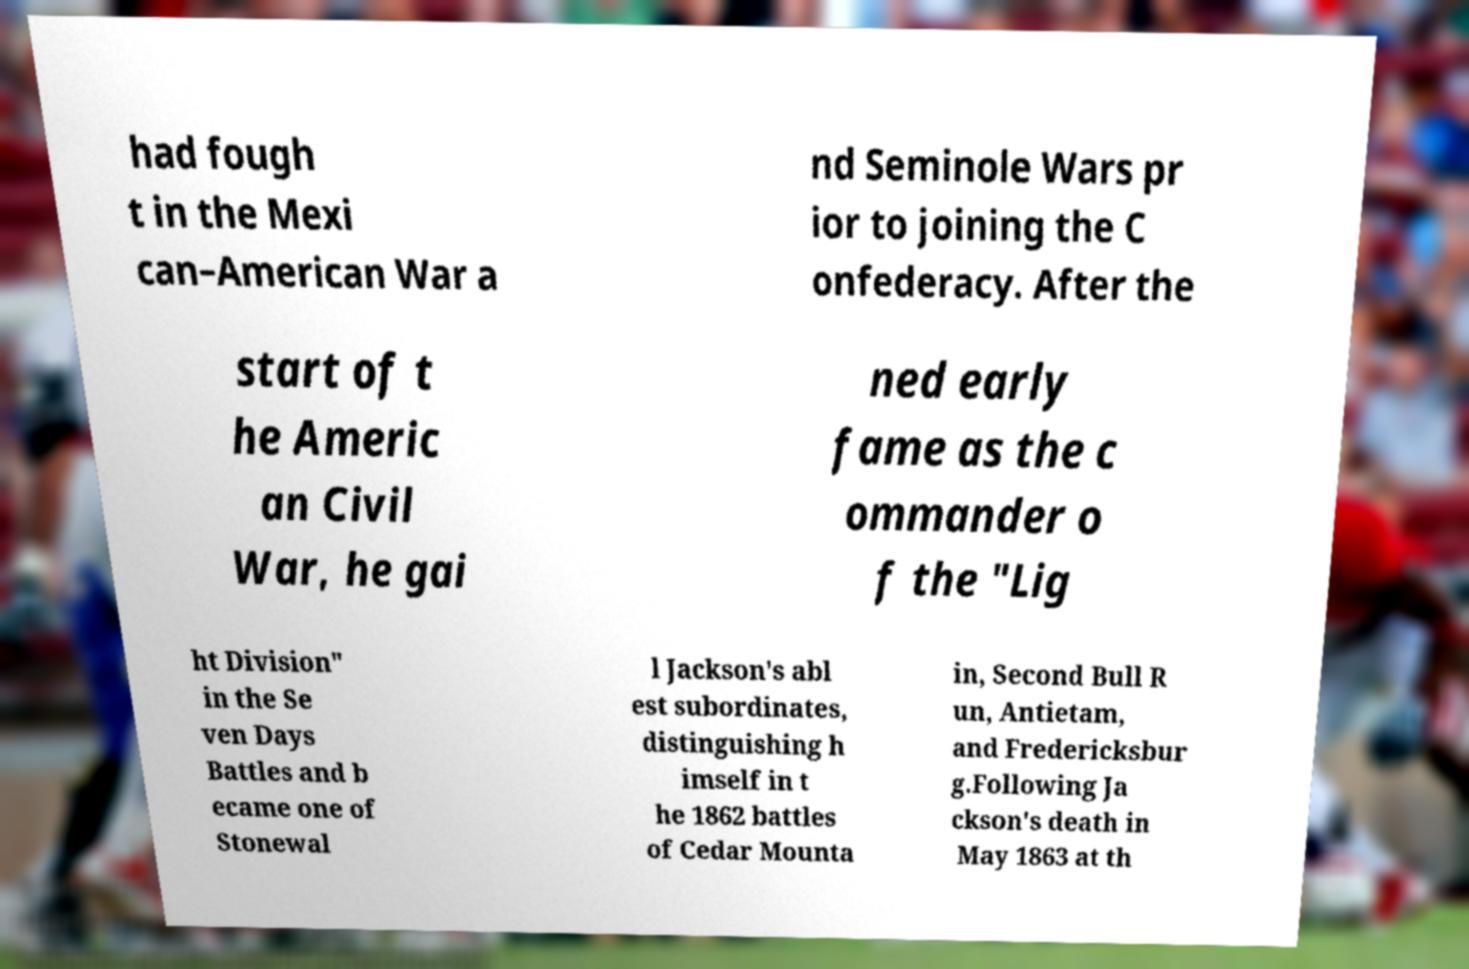Can you accurately transcribe the text from the provided image for me? had fough t in the Mexi can–American War a nd Seminole Wars pr ior to joining the C onfederacy. After the start of t he Americ an Civil War, he gai ned early fame as the c ommander o f the "Lig ht Division" in the Se ven Days Battles and b ecame one of Stonewal l Jackson's abl est subordinates, distinguishing h imself in t he 1862 battles of Cedar Mounta in, Second Bull R un, Antietam, and Fredericksbur g.Following Ja ckson's death in May 1863 at th 